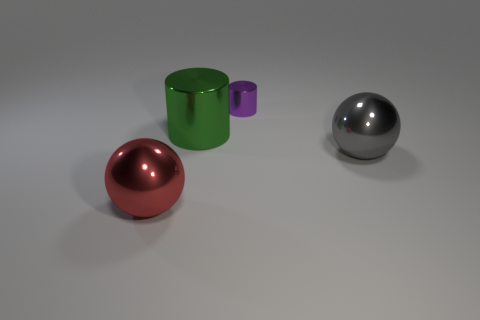Add 2 small purple cylinders. How many objects exist? 6 Subtract all gray balls. How many balls are left? 1 Add 1 large gray metal objects. How many large gray metal objects are left? 2 Add 2 large red metallic balls. How many large red metallic balls exist? 3 Subtract 1 green cylinders. How many objects are left? 3 Subtract 2 spheres. How many spheres are left? 0 Subtract all yellow cylinders. Subtract all blue blocks. How many cylinders are left? 2 Subtract all green cubes. How many red balls are left? 1 Subtract all tiny purple metal cylinders. Subtract all big gray spheres. How many objects are left? 2 